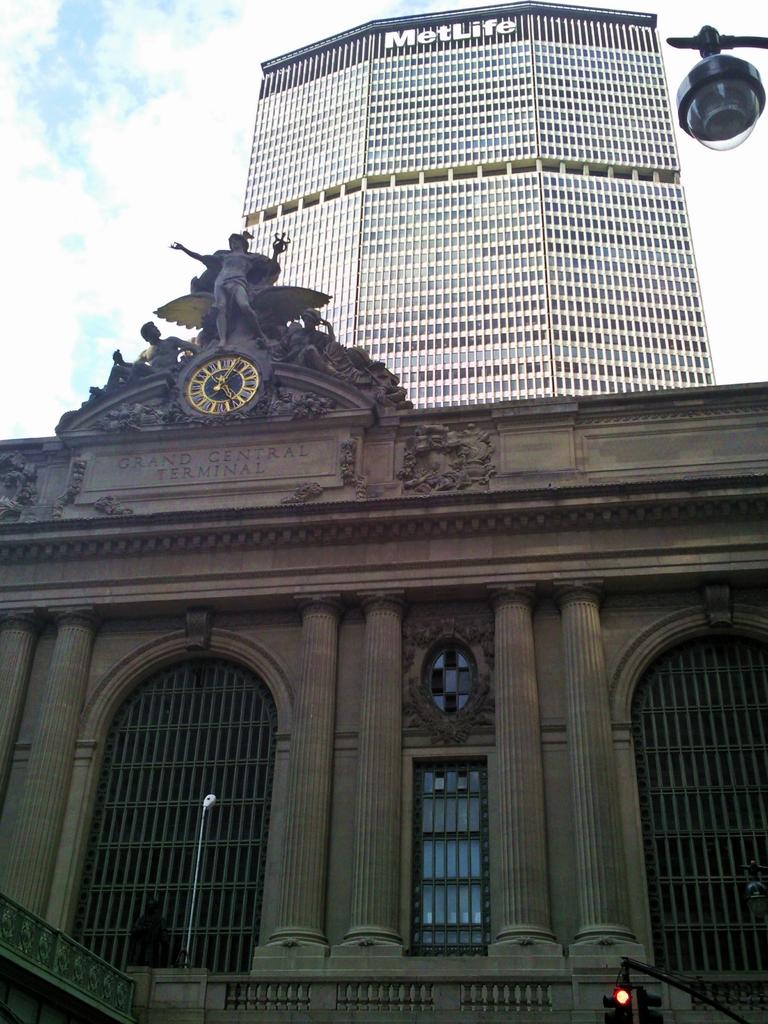What is the current time shown?
Offer a terse response. 5:05. 